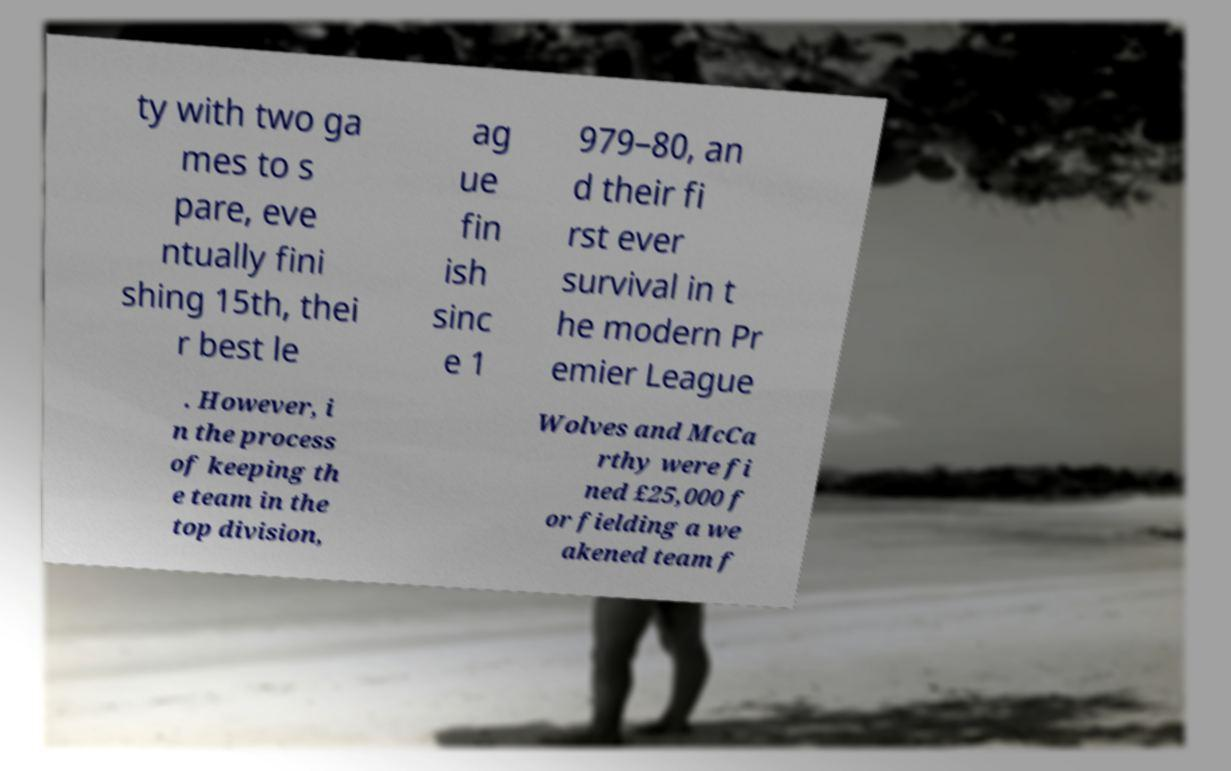Please identify and transcribe the text found in this image. ty with two ga mes to s pare, eve ntually fini shing 15th, thei r best le ag ue fin ish sinc e 1 979–80, an d their fi rst ever survival in t he modern Pr emier League . However, i n the process of keeping th e team in the top division, Wolves and McCa rthy were fi ned £25,000 f or fielding a we akened team f 